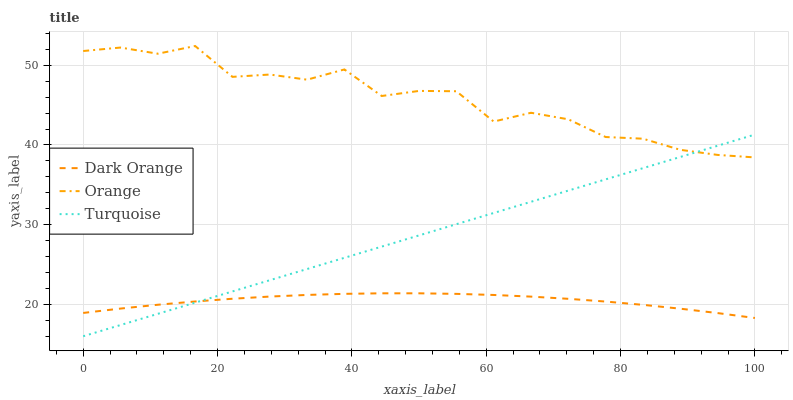Does Dark Orange have the minimum area under the curve?
Answer yes or no. Yes. Does Orange have the maximum area under the curve?
Answer yes or no. Yes. Does Turquoise have the minimum area under the curve?
Answer yes or no. No. Does Turquoise have the maximum area under the curve?
Answer yes or no. No. Is Turquoise the smoothest?
Answer yes or no. Yes. Is Orange the roughest?
Answer yes or no. Yes. Is Dark Orange the smoothest?
Answer yes or no. No. Is Dark Orange the roughest?
Answer yes or no. No. Does Dark Orange have the lowest value?
Answer yes or no. No. Does Orange have the highest value?
Answer yes or no. Yes. Does Turquoise have the highest value?
Answer yes or no. No. Is Dark Orange less than Orange?
Answer yes or no. Yes. Is Orange greater than Dark Orange?
Answer yes or no. Yes. Does Turquoise intersect Dark Orange?
Answer yes or no. Yes. Is Turquoise less than Dark Orange?
Answer yes or no. No. Is Turquoise greater than Dark Orange?
Answer yes or no. No. Does Dark Orange intersect Orange?
Answer yes or no. No. 